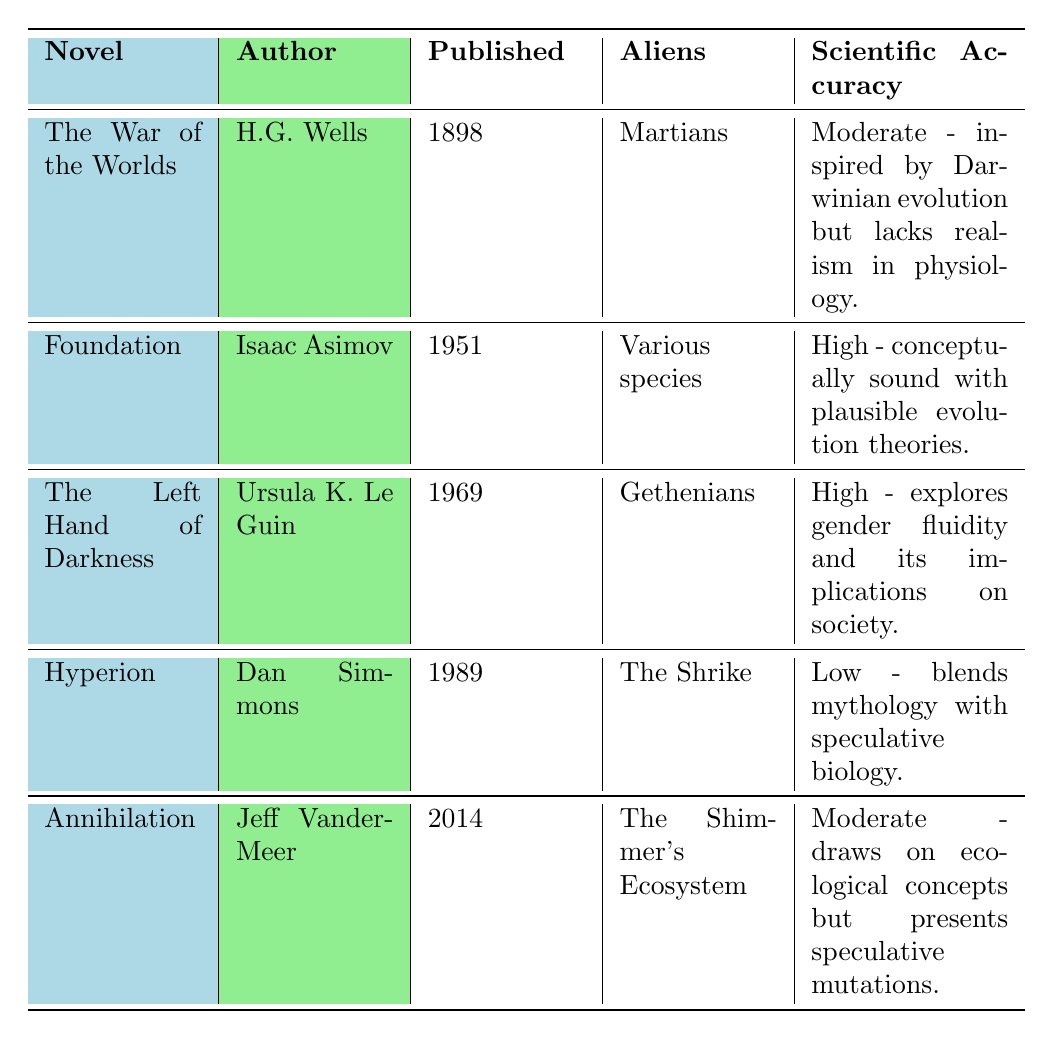What is the title of the novel by H.G. Wells? The author is mentioned in the table along with the title of the novel, which is "The War of the Worlds."
Answer: The War of the Worlds Which alien species is featured in "Annihilation"? By looking at the row corresponding to "Annihilation," it is clear that the alien species is referred to as "The Shimmer's Ecosystem."
Answer: The Shimmer's Ecosystem What year was "Foundation" published? The publication year can be directly found in the table under the "Published" column corresponding to the novel "Foundation," which shows 1951.
Answer: 1951 How many novels have a high scientific accuracy rating? There are two novels listed with a "High" scientific accuracy rating: "Foundation" and "The Left Hand of Darkness." Therefore, the count is 2.
Answer: 2 Is the physiology of the aliens in "The Left Hand of Darkness" considered realistic? The table indicates that the scientific accuracy of this novel is high, which suggests that it is considered to have a realistic portrayal of alien physiology.
Answer: Yes Which novel features alien reproduction that is seasonal and involves androgynous forms? The table directly identifies "The Left Hand of Darkness" as having a seasonal mating reproduction system with androgynous forms.
Answer: The Left Hand of Darkness What is the average publication year of the novels listed? The publication years are 1898, 1951, 1969, 1989, and 2014. The average can be calculated: (1898 + 1951 + 1969 + 1989 + 2014) / 5 = 1983.
Answer: 1983 What is the dietary classification of the aliens in "Hyperion"? The table specifies that the aliens in "Hyperion" are described as feeding on "human-like beings," indicating a form of carnivorous diet.
Answer: Carnivorous Which novel has the lowest scientific accuracy? By glancing through the scientific accuracy ratings in the table, "Hyperion" stands out with a low rating.
Answer: Hyperion Are the aliens in "The War of the Worlds" considered carnivorous? The table mentions that the diet of the Martians in "The War of the Worlds" is carnivorous, confirming this as a true statement.
Answer: Yes 